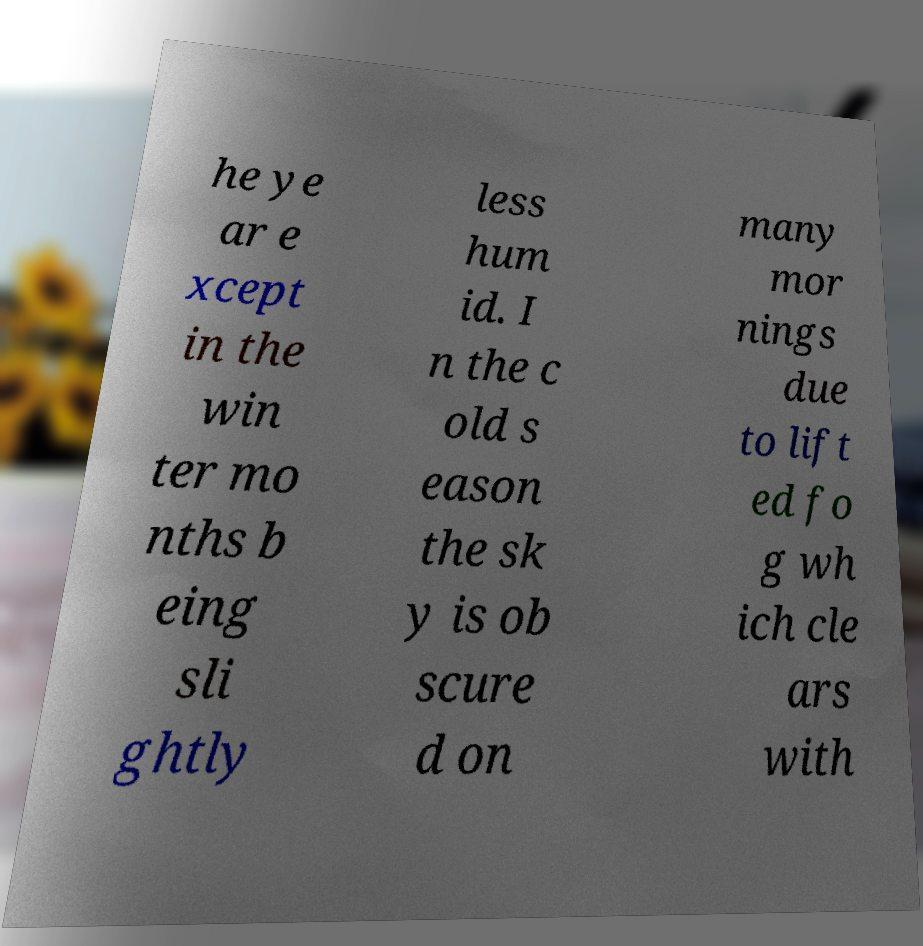What messages or text are displayed in this image? I need them in a readable, typed format. he ye ar e xcept in the win ter mo nths b eing sli ghtly less hum id. I n the c old s eason the sk y is ob scure d on many mor nings due to lift ed fo g wh ich cle ars with 